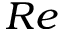Convert formula to latex. <formula><loc_0><loc_0><loc_500><loc_500>R e</formula> 